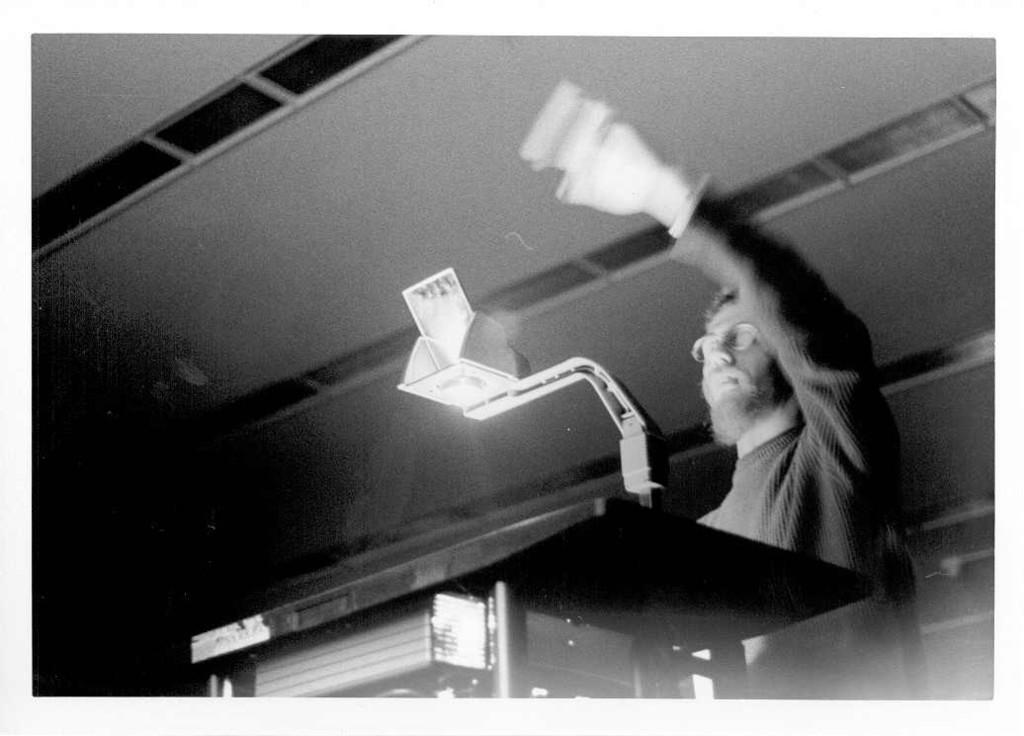Who is present in the image? There is a man in the image. What is the man doing with his hand? The man is raising his hand. What type of clothing is the man wearing? The man is wearing a sweater. What accessory is the man wearing on his face? The man is wearing spectacles. What part of a building can be seen in the image? There is a roof visible in the image. How many women are present in the image? There are no women present in the image; it features a man. Can you tell me where the airport is located in the image? There is no airport present in the image. 